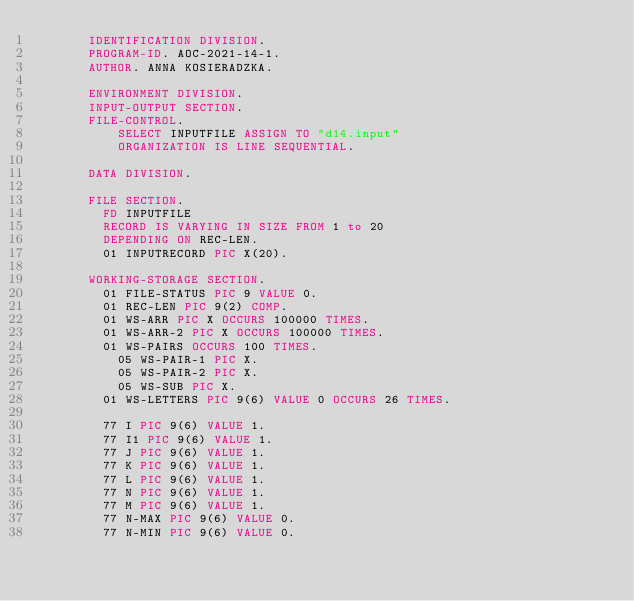Convert code to text. <code><loc_0><loc_0><loc_500><loc_500><_COBOL_>       IDENTIFICATION DIVISION.
       PROGRAM-ID. AOC-2021-14-1.
       AUTHOR. ANNA KOSIERADZKA.

       ENVIRONMENT DIVISION.
       INPUT-OUTPUT SECTION.
       FILE-CONTROL.
           SELECT INPUTFILE ASSIGN TO "d14.input"
           ORGANIZATION IS LINE SEQUENTIAL.

       DATA DIVISION.

       FILE SECTION.
         FD INPUTFILE
         RECORD IS VARYING IN SIZE FROM 1 to 20
         DEPENDING ON REC-LEN.
         01 INPUTRECORD PIC X(20).

       WORKING-STORAGE SECTION.
         01 FILE-STATUS PIC 9 VALUE 0.
         01 REC-LEN PIC 9(2) COMP.
         01 WS-ARR PIC X OCCURS 100000 TIMES.
         01 WS-ARR-2 PIC X OCCURS 100000 TIMES.
         01 WS-PAIRS OCCURS 100 TIMES.
           05 WS-PAIR-1 PIC X.
           05 WS-PAIR-2 PIC X.
           05 WS-SUB PIC X.
         01 WS-LETTERS PIC 9(6) VALUE 0 OCCURS 26 TIMES.

         77 I PIC 9(6) VALUE 1.
         77 I1 PIC 9(6) VALUE 1.
         77 J PIC 9(6) VALUE 1.
         77 K PIC 9(6) VALUE 1.
         77 L PIC 9(6) VALUE 1.
         77 N PIC 9(6) VALUE 1.
         77 M PIC 9(6) VALUE 1. 
         77 N-MAX PIC 9(6) VALUE 0. 
         77 N-MIN PIC 9(6) VALUE 0.</code> 